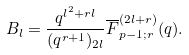<formula> <loc_0><loc_0><loc_500><loc_500>B _ { l } = \frac { q ^ { l ^ { 2 } + r l } } { ( q ^ { r + 1 } ) _ { 2 l } } \overline { F } _ { p - 1 ; r } ^ { ( 2 l + r ) } ( q ) .</formula> 